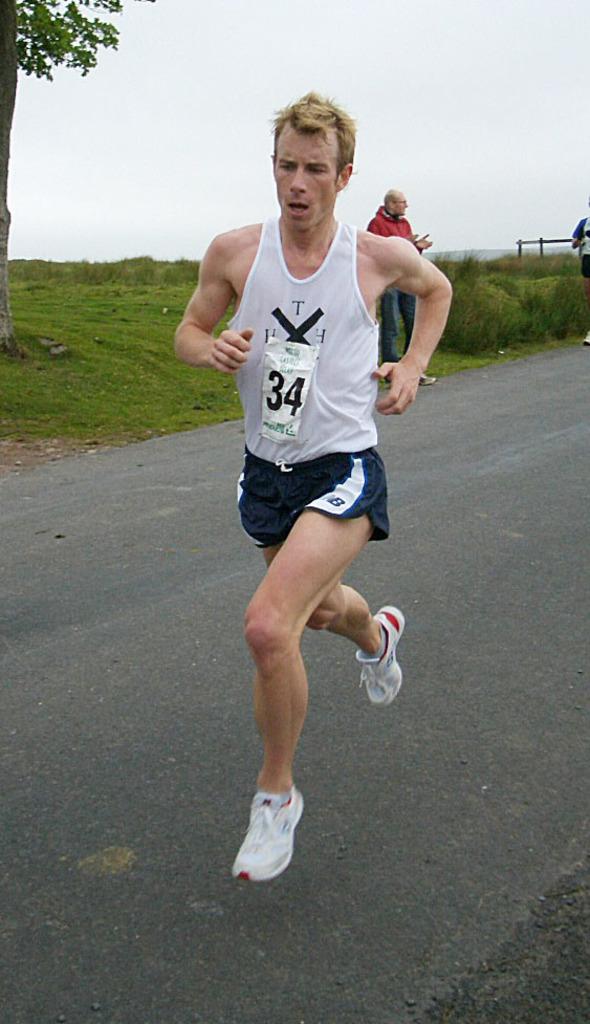What letter is at the top of the runner's shirt?
Make the answer very short. T. 